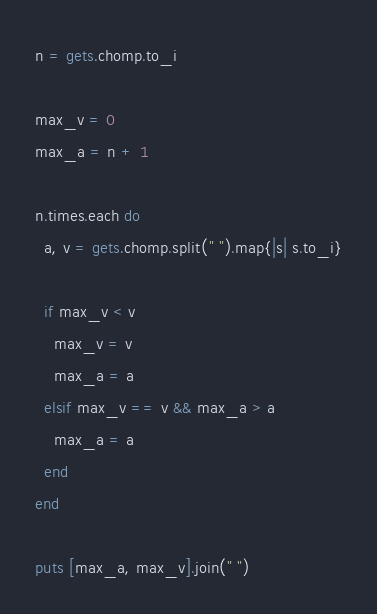Convert code to text. <code><loc_0><loc_0><loc_500><loc_500><_Ruby_>n = gets.chomp.to_i

max_v = 0
max_a = n + 1

n.times.each do
  a, v = gets.chomp.split(" ").map{|s| s.to_i}

  if max_v < v
    max_v = v
    max_a = a
  elsif max_v == v && max_a > a
    max_a = a
  end
end

puts [max_a, max_v].join(" ")</code> 